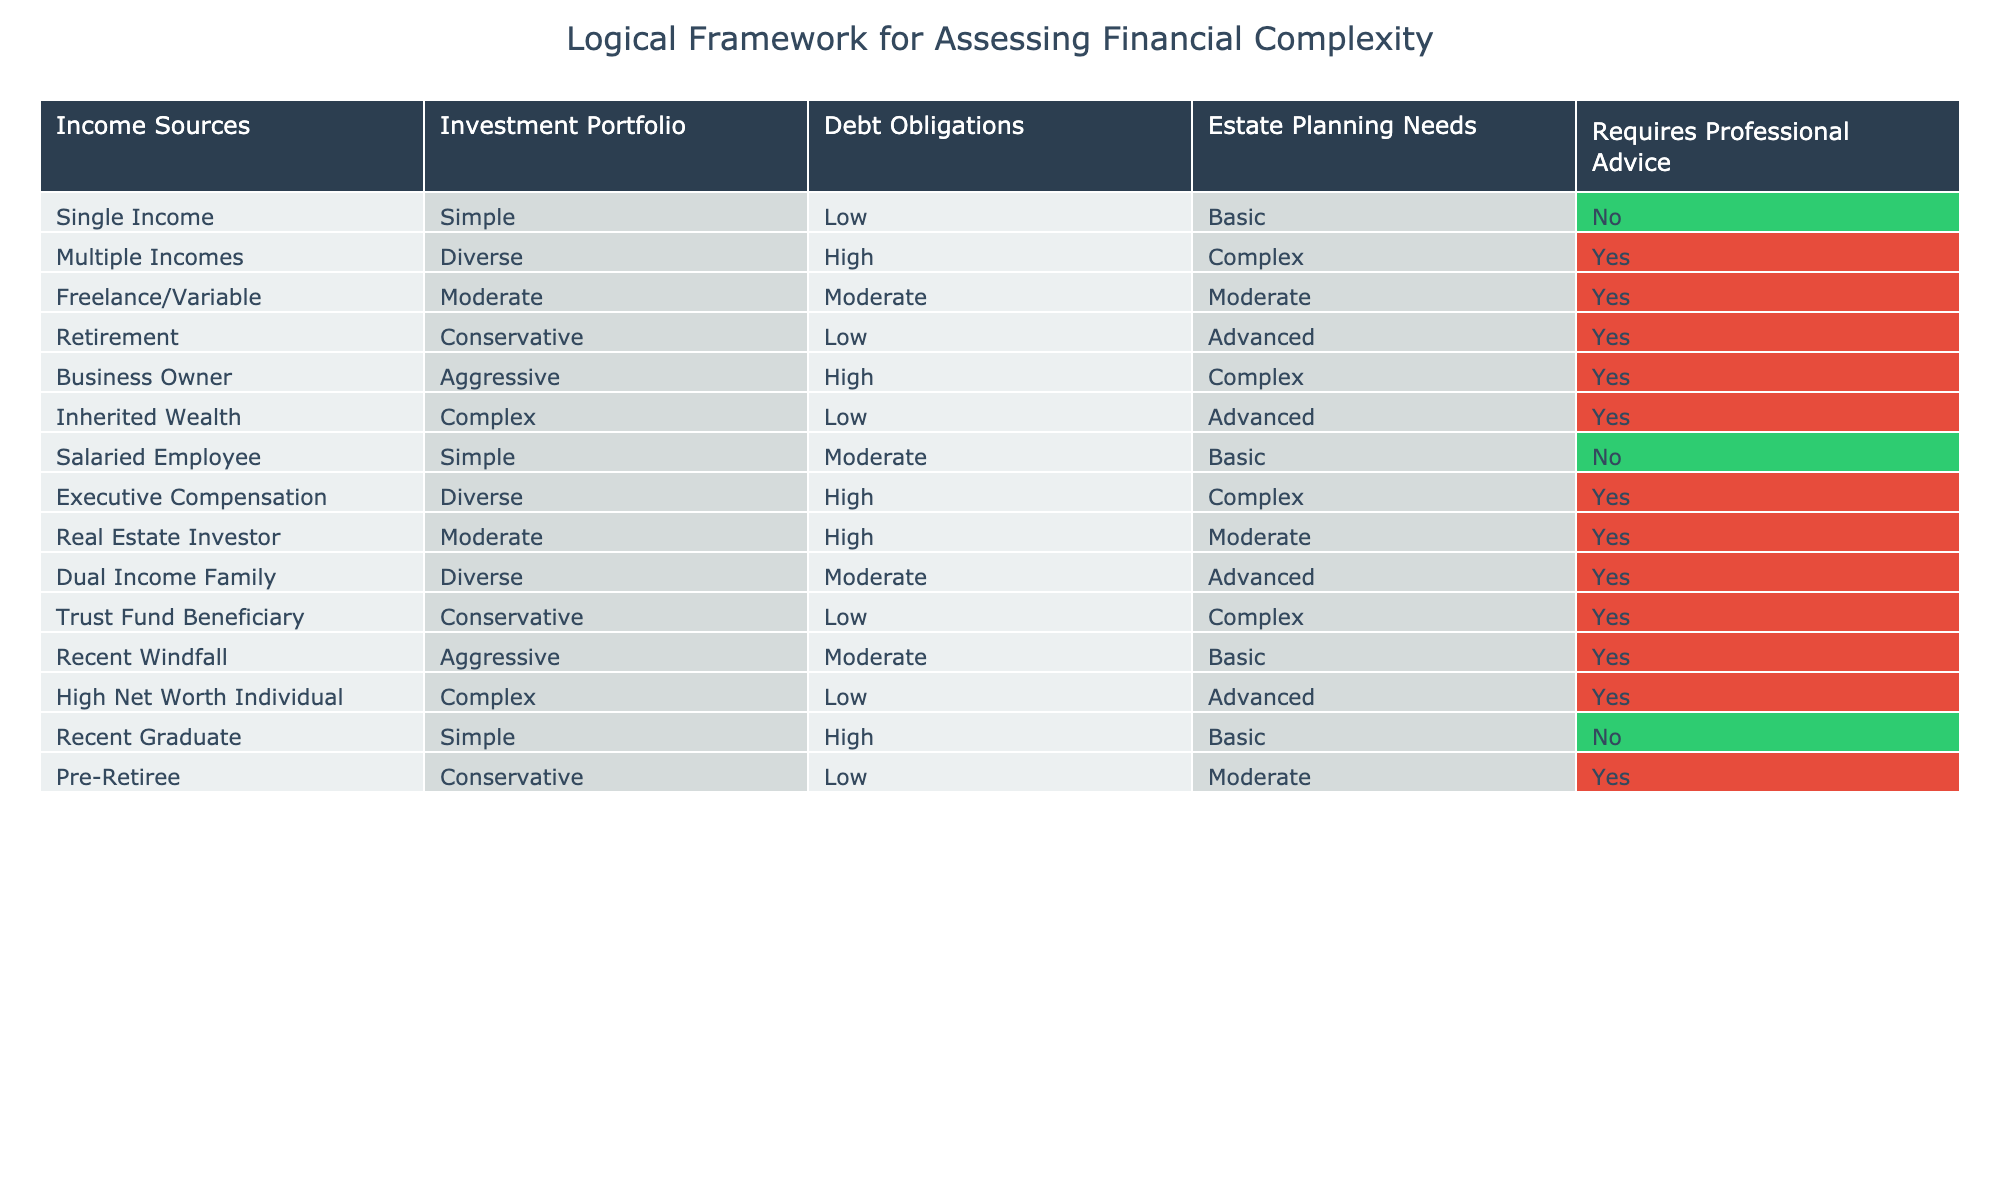What is the maximum number of income sources that require professional advice? By looking at the table, we can see that both "Multiple Incomes" and "Executive Compensation" are listed under "Requires Professional Advice." Thus, the maximum number of income sources in this category is 2.
Answer: 2 How many financial situations listed under 'Debt Obligations' are categorized as 'High'? In the table, we can find five situations with "High" under "Debt Obligations": "Multiple Incomes," "Business Owner," "Executive Compensation," "Real Estate Investor," and "Recent Graduate." Thus, there are 5 situations categorized as "High."
Answer: 5 Is a salaried employee's financial situation complex? A "Salaried Employee" is listed as having a "Simple" financial situation. Therefore, the statement is false and the answer is 'No.'
Answer: No Which income source with a moderate investment portfolio does not require professional advice? By examining the table, the "Recent Graduate" has a "Simple" income source paired with "High" under "Debt Obligations." On the other hand, "Real Estate Investor" has a "Moderate" portfolio alongside "High" debt obligations. Thus, the income source with a "Moderate" portfolio that does not require professional advice is seen through deduction.
Answer: Real Estate Investor What is the average complexity level of financial situations that require professional advice? In the table, the complexity levels for those requiring advice are "Complex" (Multiple Incomes, Business Owner, Executive Compensation, and Trust Fund Beneficiary), "Advanced" (Retirement, Dual Income Family, and High Net Worth Individual), and "Moderate" (Freelance/Variable and Pre-Retiree). Evaluating these shows 7 complexity levels overall. "Complex" appears 4 times (score of 2), "Advanced" 3 times (score of 1), and "Moderate" 2 times (score of 0). We can calculate the average: (4*2 + 3*1 + 2*0) / 9 = 8 / 9 = 1.33. Therefore, the average complexity level is closer to "Complex."
Answer: 1.33 How many instances have estate planning needs categorized as 'Complex'? If we review the table specifically for the "Estate Planning Needs" category, we note "Business Owner," "Dual Income Family," and "Trust Fund Beneficiary" among the situations demand it. That's three instances of complexity in estate planning needs.
Answer: 3 